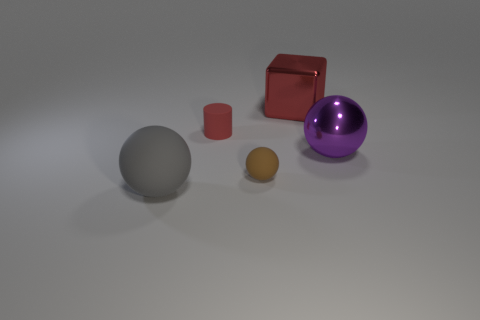How big is the red object that is to the right of the brown thing?
Provide a succinct answer. Large. There is a shiny block; is its color the same as the matte thing behind the small brown object?
Offer a terse response. Yes. Are there any tiny rubber cubes that have the same color as the big rubber ball?
Your response must be concise. No. Is the small red cylinder made of the same material as the large sphere that is to the right of the gray ball?
Provide a short and direct response. No. What number of big objects are purple blocks or red things?
Your response must be concise. 1. There is a tiny cylinder that is the same color as the large shiny block; what is its material?
Offer a terse response. Rubber. Are there fewer small red rubber objects than tiny matte things?
Provide a short and direct response. Yes. There is a matte sphere behind the large matte object; does it have the same size as the rubber thing behind the purple shiny object?
Your response must be concise. Yes. What number of gray objects are either spheres or metallic spheres?
Your answer should be compact. 1. What is the size of the matte cylinder that is the same color as the big metal block?
Your response must be concise. Small. 